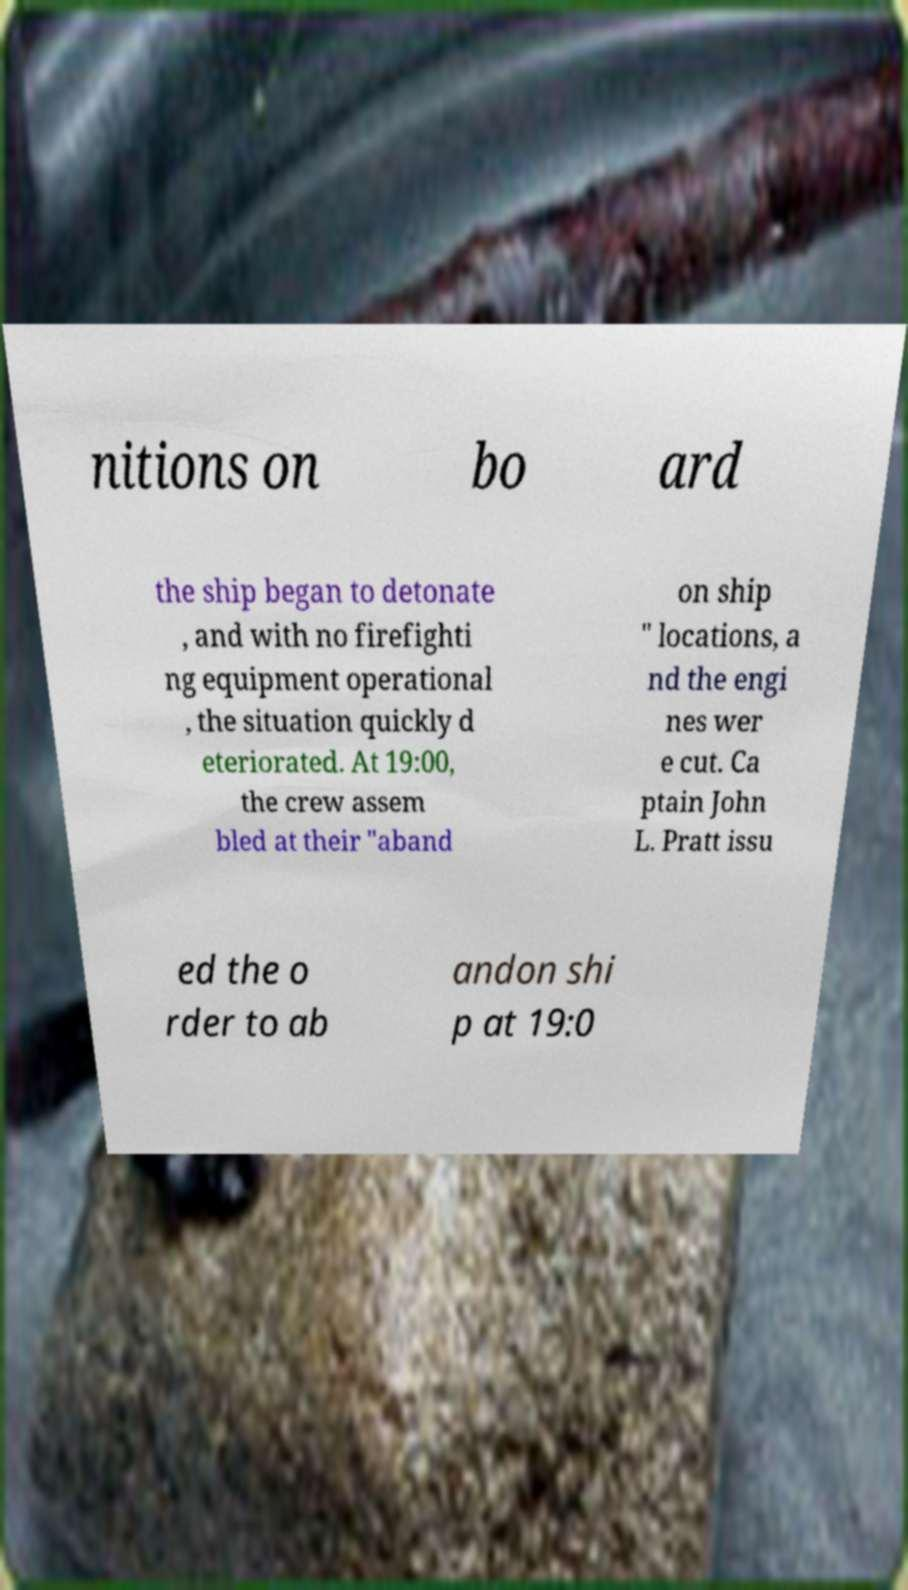Can you accurately transcribe the text from the provided image for me? nitions on bo ard the ship began to detonate , and with no firefighti ng equipment operational , the situation quickly d eteriorated. At 19:00, the crew assem bled at their "aband on ship " locations, a nd the engi nes wer e cut. Ca ptain John L. Pratt issu ed the o rder to ab andon shi p at 19:0 